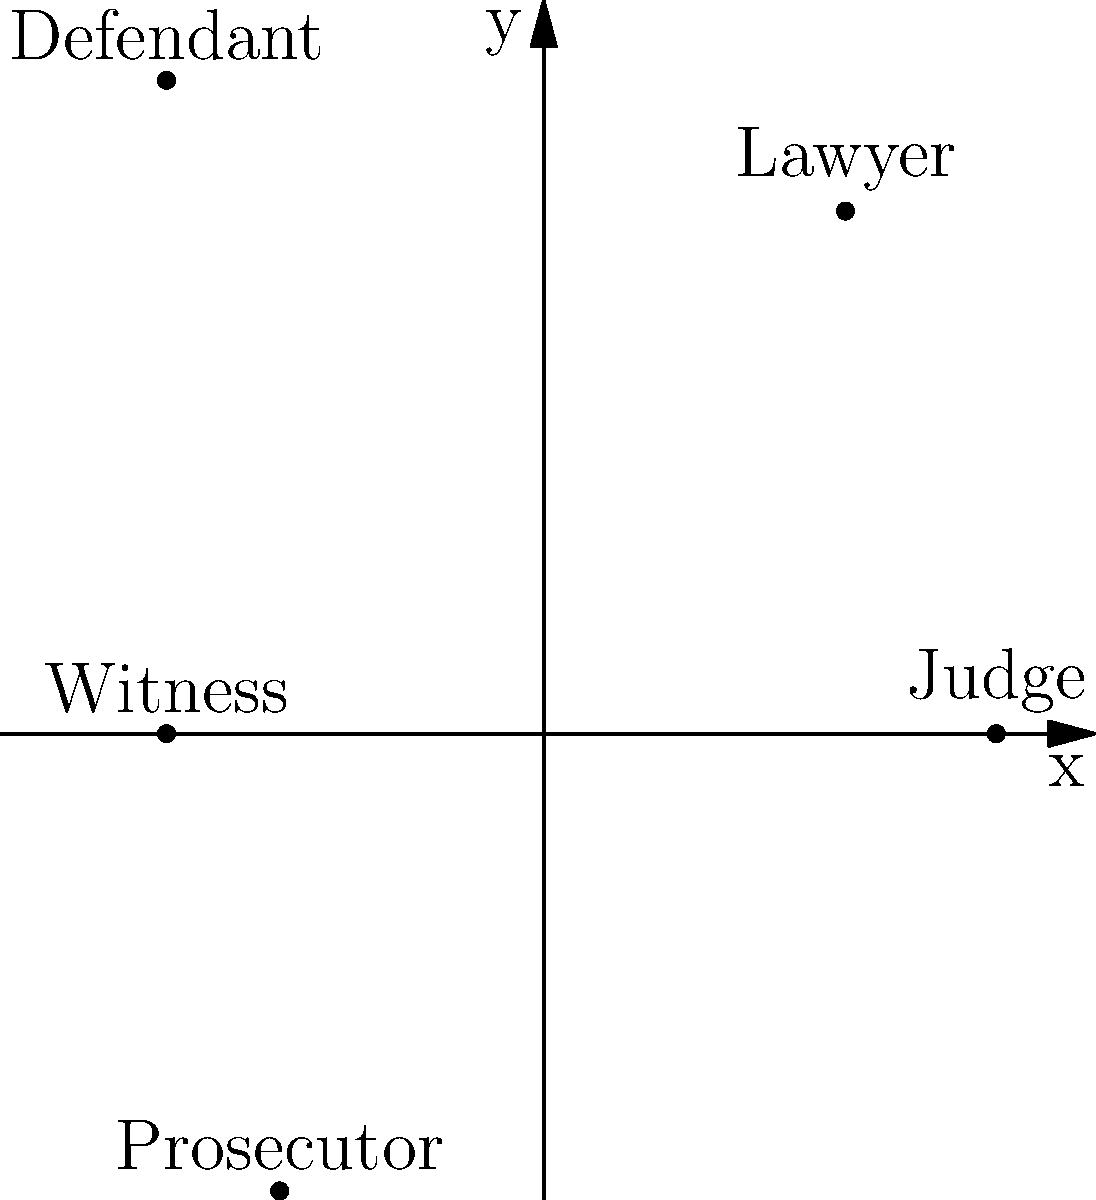In a complex legal thriller, character relationships are mapped using polar coordinates. The protagonist judge is positioned at $(3,0)$. If the lawyer is at an angle of $\frac{\pi}{3}$ radians from the positive x-axis and a distance of 4 units from the origin, what is the Euclidean distance between the judge and the lawyer? Let's approach this step-by-step:

1) The judge's position in polar coordinates is $(r_1, \theta_1) = (3, 0)$, which in Cartesian coordinates is $(x_1, y_1) = (3, 0)$.

2) The lawyer's position in polar coordinates is $(r_2, \theta_2) = (4, \frac{\pi}{3})$. We need to convert this to Cartesian coordinates:
   $x_2 = r_2 \cos(\theta_2) = 4 \cos(\frac{\pi}{3}) = 4 \cdot \frac{1}{2} = 2$
   $y_2 = r_2 \sin(\theta_2) = 4 \sin(\frac{\pi}{3}) = 4 \cdot \frac{\sqrt{3}}{2} = 2\sqrt{3}$

3) Now we have the Cartesian coordinates for both characters:
   Judge: $(3, 0)$
   Lawyer: $(2, 2\sqrt{3})$

4) To find the Euclidean distance, we use the distance formula:
   $d = \sqrt{(x_2 - x_1)^2 + (y_2 - y_1)^2}$

5) Plugging in our values:
   $d = \sqrt{(2 - 3)^2 + (2\sqrt{3} - 0)^2}$

6) Simplify:
   $d = \sqrt{(-1)^2 + (2\sqrt{3})^2} = \sqrt{1 + 12} = \sqrt{13}$

Therefore, the Euclidean distance between the judge and the lawyer is $\sqrt{13}$ units.
Answer: $\sqrt{13}$ units 